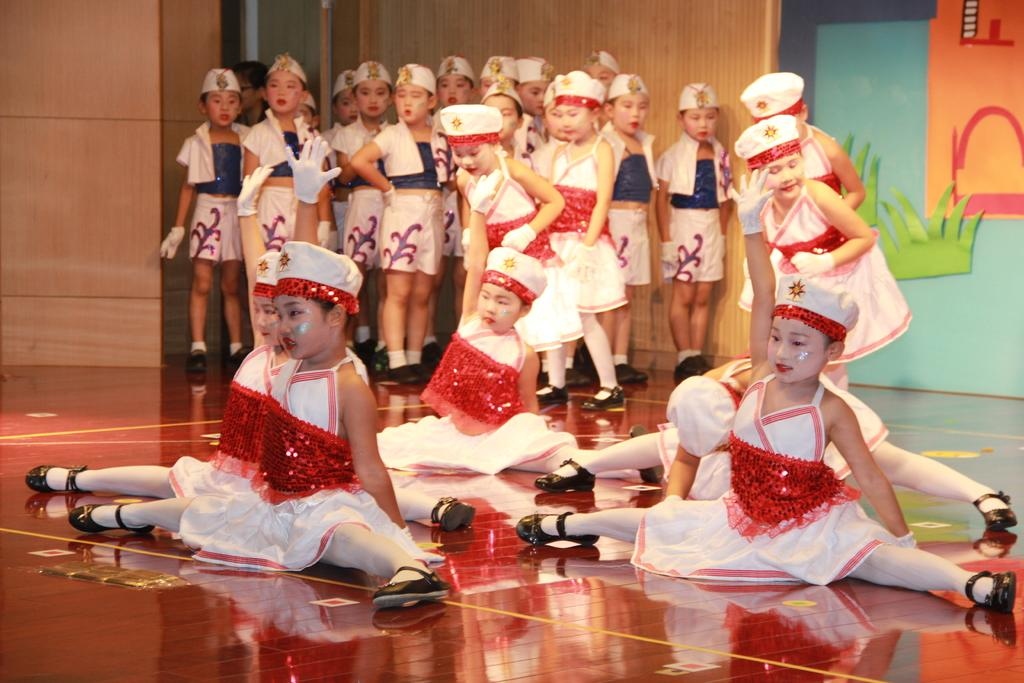What are the people in the image doing? The people in the image are sitting on the floor and standing at the back. What can be seen in the background of the image? There is art and a painting in the background of the image. What type of lumber is being used to create the doll in the image? There is no doll or lumber present in the image. How many cherries are visible on the painting in the background? There is no mention of cherries in the image, and the painting in the background is not described in detail. 